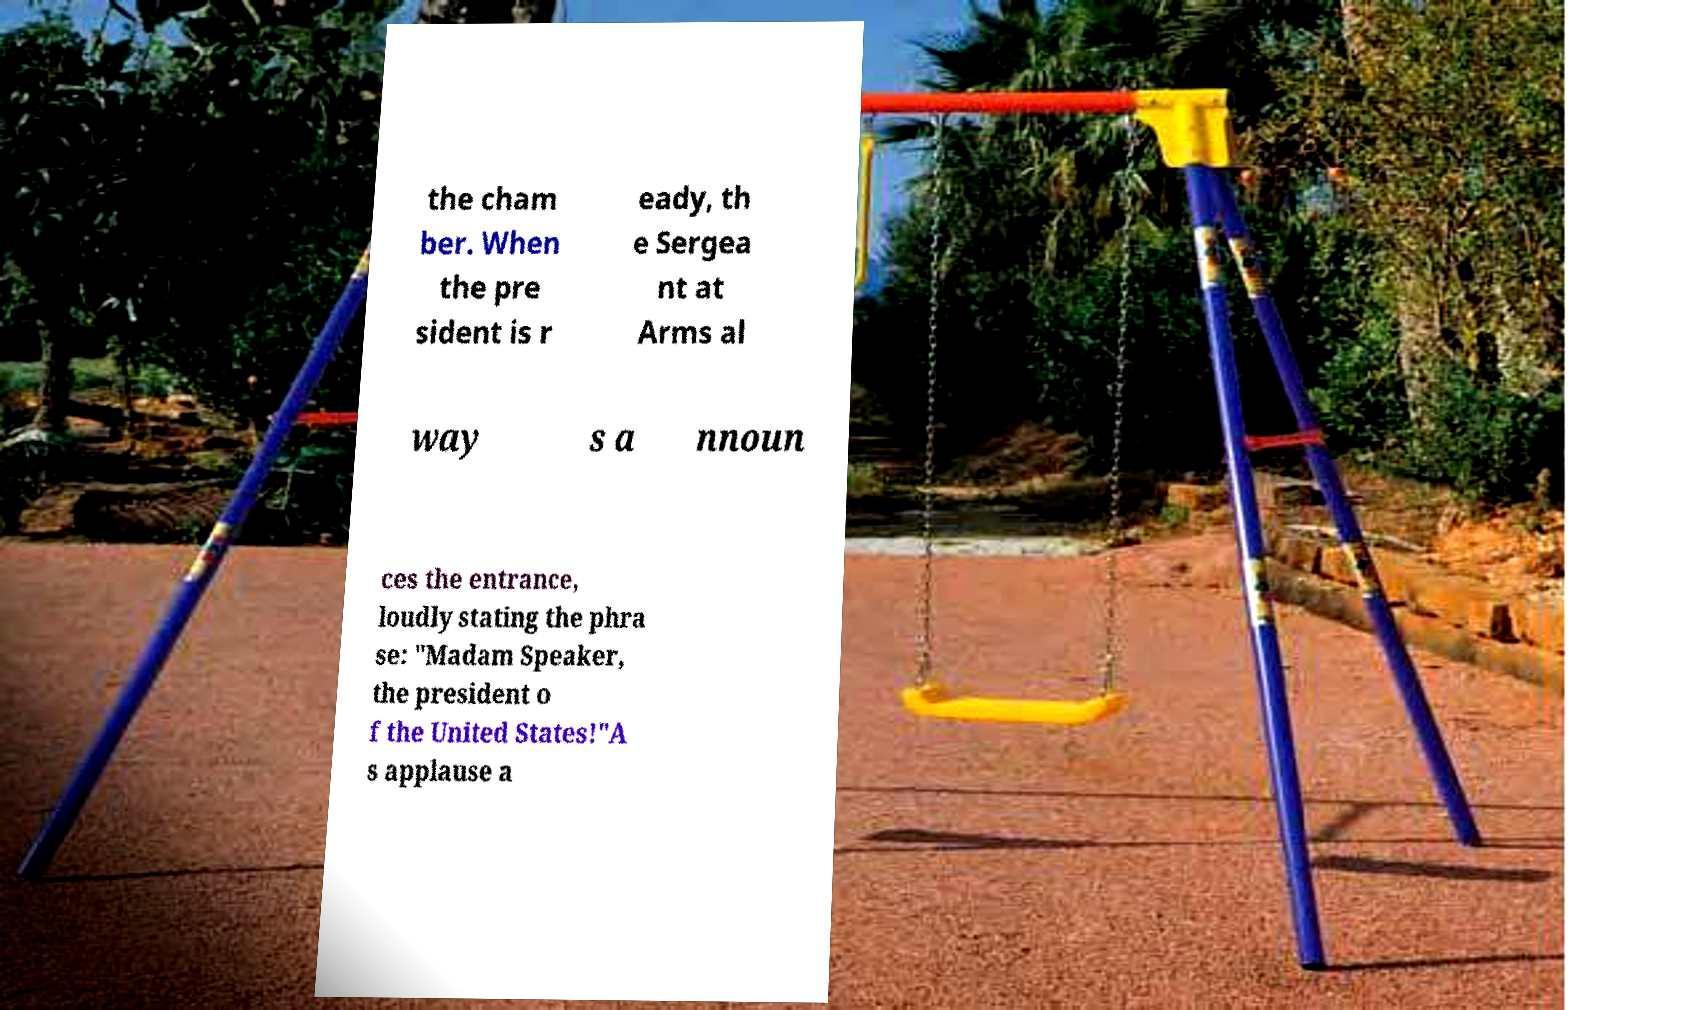For documentation purposes, I need the text within this image transcribed. Could you provide that? the cham ber. When the pre sident is r eady, th e Sergea nt at Arms al way s a nnoun ces the entrance, loudly stating the phra se: "Madam Speaker, the president o f the United States!"A s applause a 